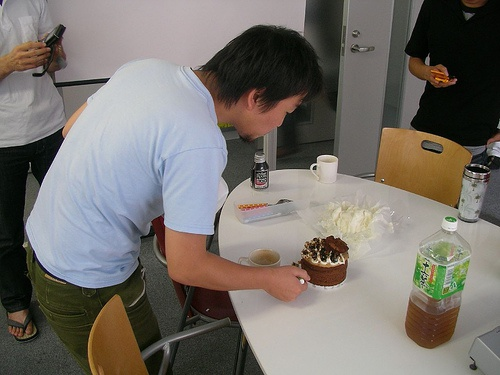Describe the objects in this image and their specific colors. I can see people in black, darkgray, lightgray, and brown tones, dining table in black, darkgray, gray, and maroon tones, people in black, darkgray, and gray tones, people in black, maroon, and gray tones, and bottle in black, maroon, darkgray, olive, and green tones in this image. 